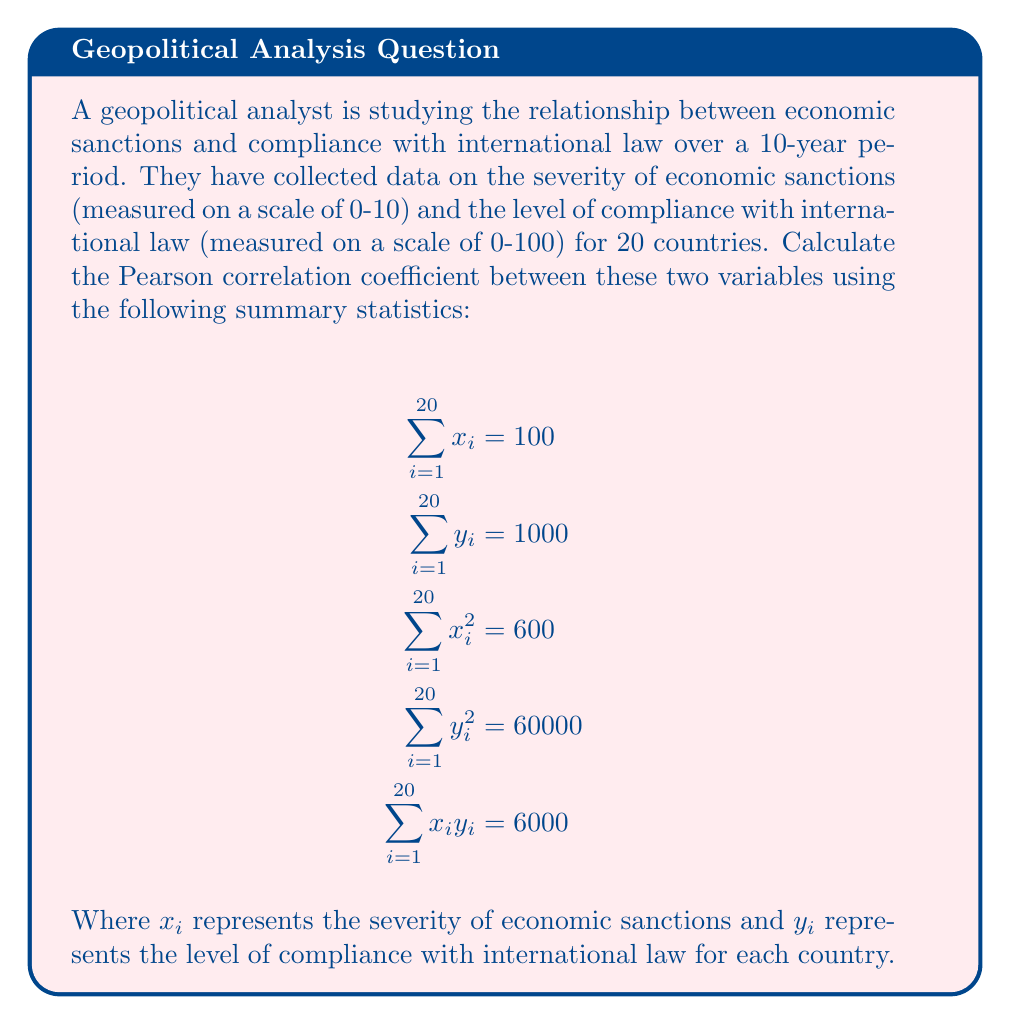Teach me how to tackle this problem. To calculate the Pearson correlation coefficient, we'll use the formula:

$$r = \frac{n\sum x_iy_i - (\sum x_i)(\sum y_i)}{\sqrt{[n\sum x_i^2 - (\sum x_i)^2][n\sum y_i^2 - (\sum y_i)^2]}}$$

Where:
$n$ is the number of observations (countries) = 20
$\sum x_iy_i = 6000$
$\sum x_i = 100$
$\sum y_i = 1000$
$\sum x_i^2 = 600$
$\sum y_i^2 = 60000$

Let's calculate step by step:

1. Numerator:
   $20 * 6000 - (100 * 1000) = 120000 - 100000 = 20000$

2. Denominator:
   a. First part: $20 * 600 - 100^2 = 12000 - 10000 = 2000$
   b. Second part: $20 * 60000 - 1000^2 = 1200000 - 1000000 = 200000$
   c. Product: $\sqrt{2000 * 200000} = \sqrt{400000000} = 20000$

3. Correlation coefficient:
   $r = \frac{20000}{20000} = 1$

The Pearson correlation coefficient is 1, indicating a perfect positive linear correlation between the severity of economic sanctions and compliance with international law in this dataset.
Answer: $r = 1$ 